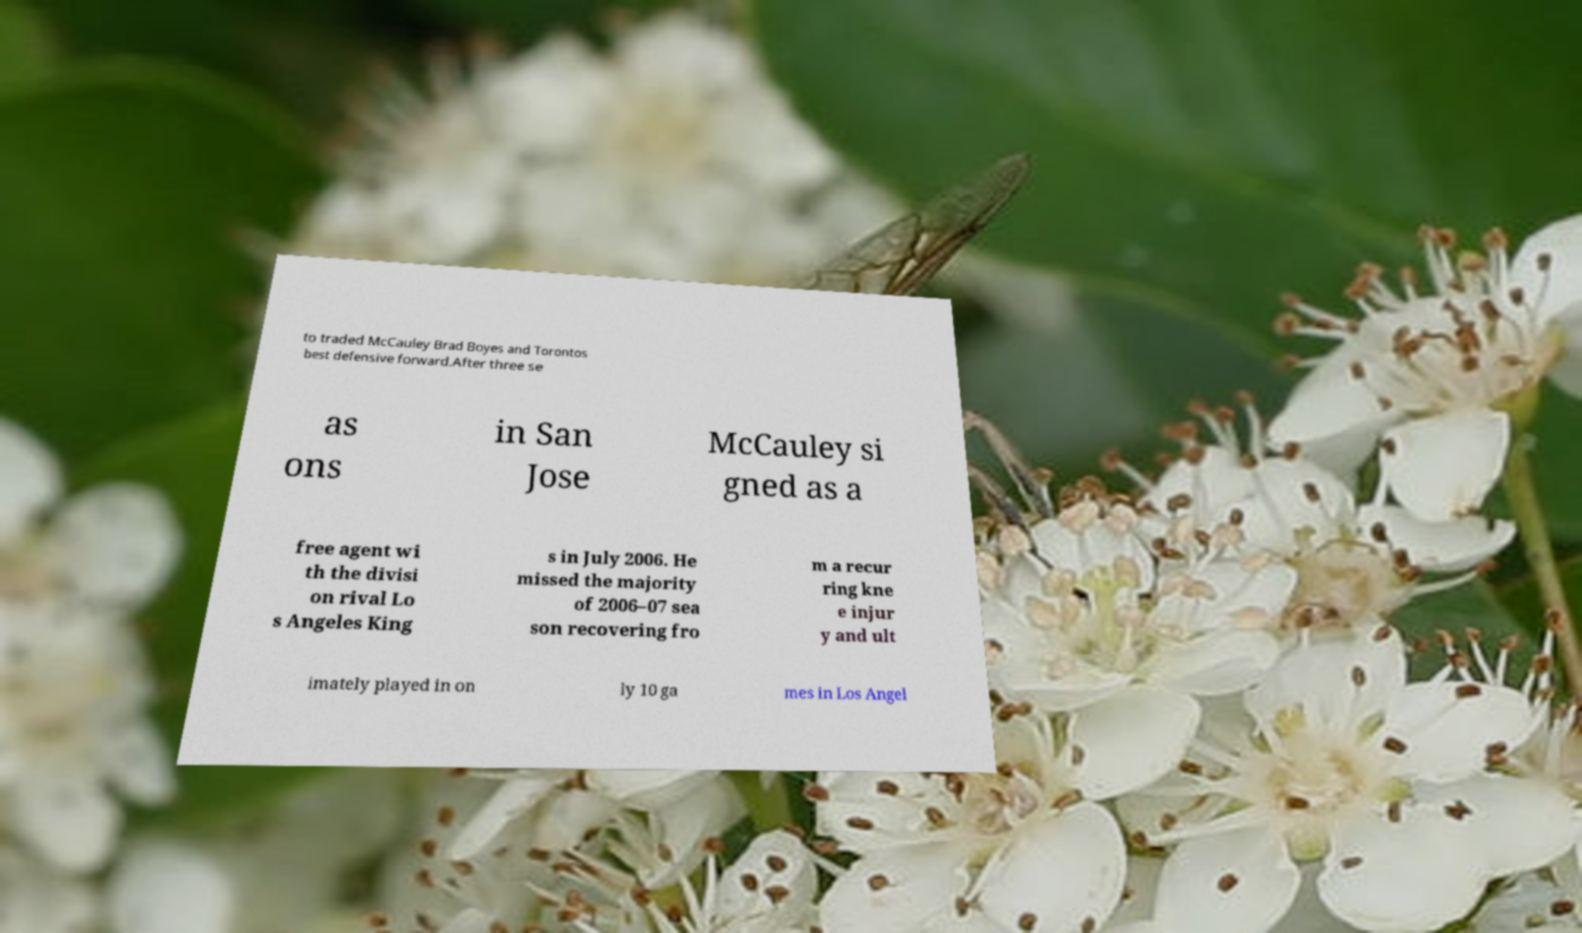Please identify and transcribe the text found in this image. to traded McCauley Brad Boyes and Torontos best defensive forward.After three se as ons in San Jose McCauley si gned as a free agent wi th the divisi on rival Lo s Angeles King s in July 2006. He missed the majority of 2006–07 sea son recovering fro m a recur ring kne e injur y and ult imately played in on ly 10 ga mes in Los Angel 